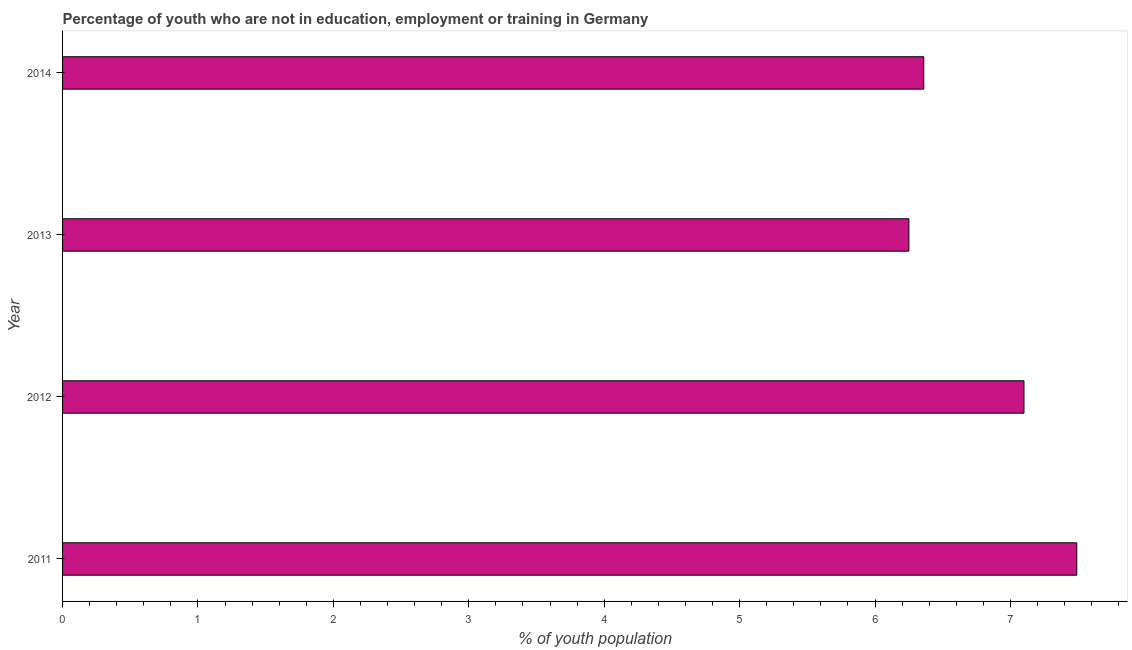Does the graph contain any zero values?
Your response must be concise. No. What is the title of the graph?
Your answer should be very brief. Percentage of youth who are not in education, employment or training in Germany. What is the label or title of the X-axis?
Provide a succinct answer. % of youth population. What is the unemployed youth population in 2014?
Give a very brief answer. 6.36. Across all years, what is the maximum unemployed youth population?
Keep it short and to the point. 7.49. Across all years, what is the minimum unemployed youth population?
Give a very brief answer. 6.25. In which year was the unemployed youth population maximum?
Keep it short and to the point. 2011. What is the sum of the unemployed youth population?
Provide a short and direct response. 27.2. What is the difference between the unemployed youth population in 2011 and 2013?
Offer a terse response. 1.24. What is the median unemployed youth population?
Ensure brevity in your answer.  6.73. In how many years, is the unemployed youth population greater than 1 %?
Offer a terse response. 4. What is the ratio of the unemployed youth population in 2012 to that in 2014?
Make the answer very short. 1.12. Is the difference between the unemployed youth population in 2012 and 2014 greater than the difference between any two years?
Make the answer very short. No. What is the difference between the highest and the second highest unemployed youth population?
Make the answer very short. 0.39. What is the difference between the highest and the lowest unemployed youth population?
Offer a terse response. 1.24. In how many years, is the unemployed youth population greater than the average unemployed youth population taken over all years?
Your answer should be very brief. 2. Are all the bars in the graph horizontal?
Your response must be concise. Yes. How many years are there in the graph?
Offer a very short reply. 4. Are the values on the major ticks of X-axis written in scientific E-notation?
Ensure brevity in your answer.  No. What is the % of youth population in 2011?
Give a very brief answer. 7.49. What is the % of youth population in 2012?
Offer a terse response. 7.1. What is the % of youth population in 2013?
Provide a succinct answer. 6.25. What is the % of youth population of 2014?
Your answer should be compact. 6.36. What is the difference between the % of youth population in 2011 and 2012?
Give a very brief answer. 0.39. What is the difference between the % of youth population in 2011 and 2013?
Make the answer very short. 1.24. What is the difference between the % of youth population in 2011 and 2014?
Provide a succinct answer. 1.13. What is the difference between the % of youth population in 2012 and 2014?
Offer a terse response. 0.74. What is the difference between the % of youth population in 2013 and 2014?
Keep it short and to the point. -0.11. What is the ratio of the % of youth population in 2011 to that in 2012?
Give a very brief answer. 1.05. What is the ratio of the % of youth population in 2011 to that in 2013?
Offer a terse response. 1.2. What is the ratio of the % of youth population in 2011 to that in 2014?
Give a very brief answer. 1.18. What is the ratio of the % of youth population in 2012 to that in 2013?
Your response must be concise. 1.14. What is the ratio of the % of youth population in 2012 to that in 2014?
Offer a very short reply. 1.12. What is the ratio of the % of youth population in 2013 to that in 2014?
Offer a terse response. 0.98. 